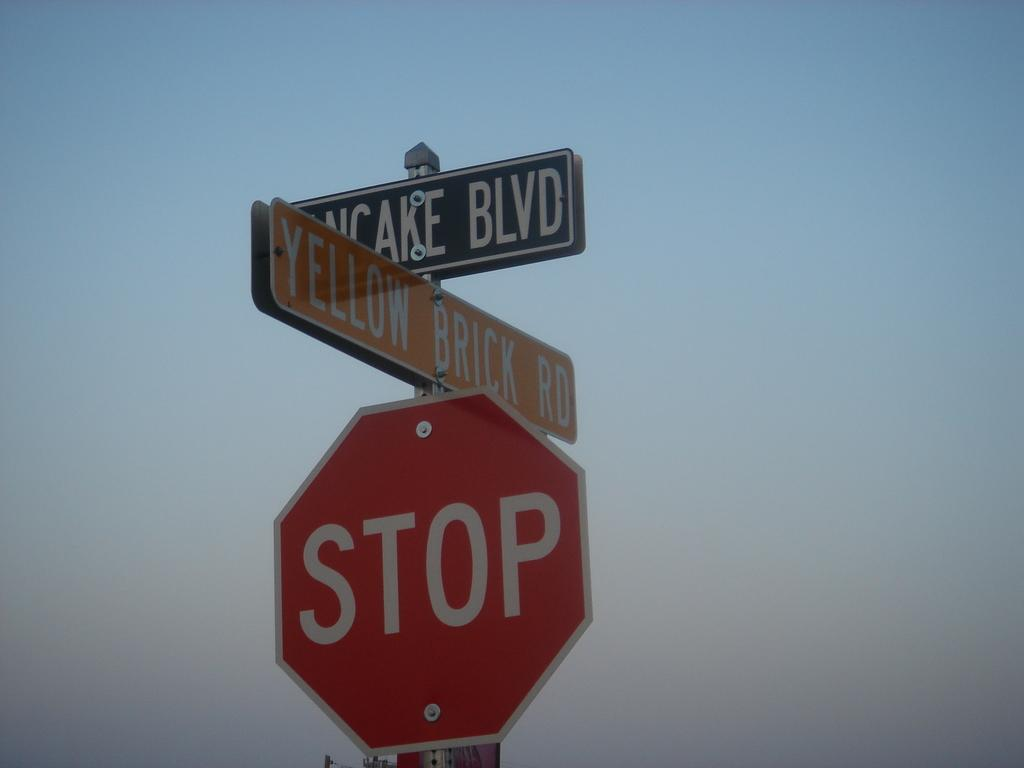<image>
Write a terse but informative summary of the picture. A red stop sign has two street signs above it that say Cake Blvd and Yellow Brick Rd. 